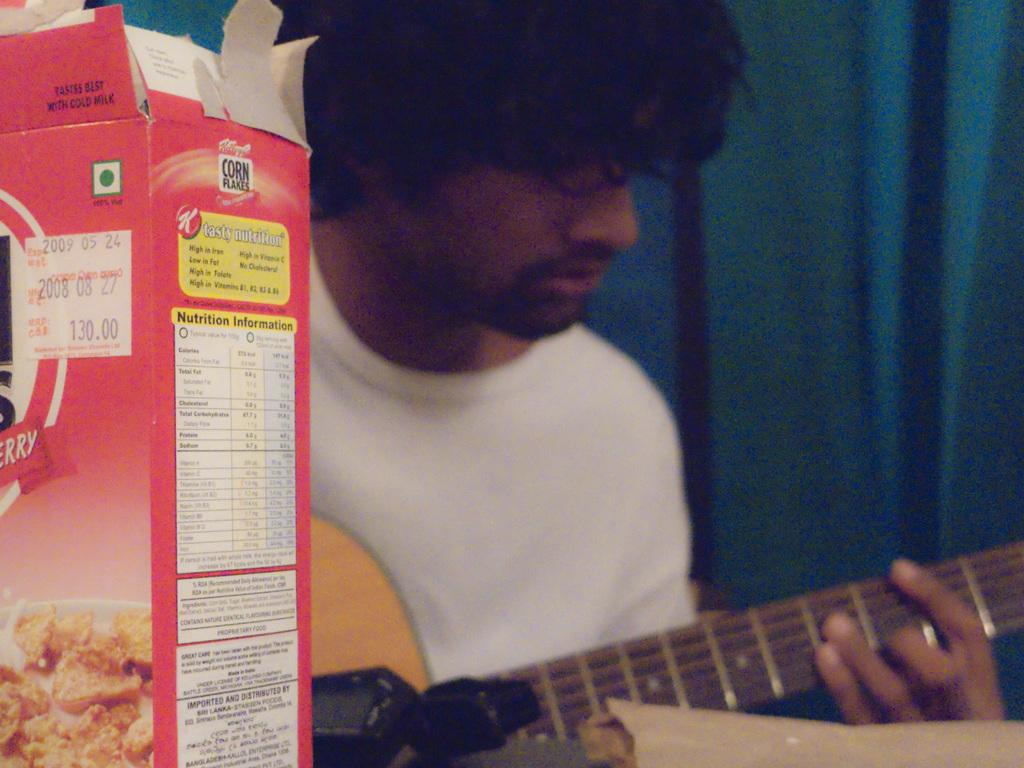What is the man in the image holding? The man is holding a guitar in the image. What other object can be seen in the image besides the guitar? There is a corn flakes box in the image. What type of science experiment is the man conducting with the stick in the image? There is no stick or science experiment present in the image. 